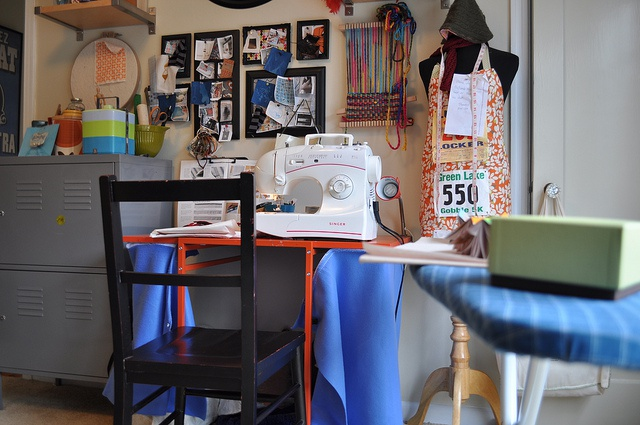Describe the objects in this image and their specific colors. I can see dining table in black, gray, lightblue, and lightgray tones, chair in black, navy, darkgray, and gray tones, bowl in black, olive, darkgreen, and gray tones, and scissors in black, gray, maroon, and brown tones in this image. 